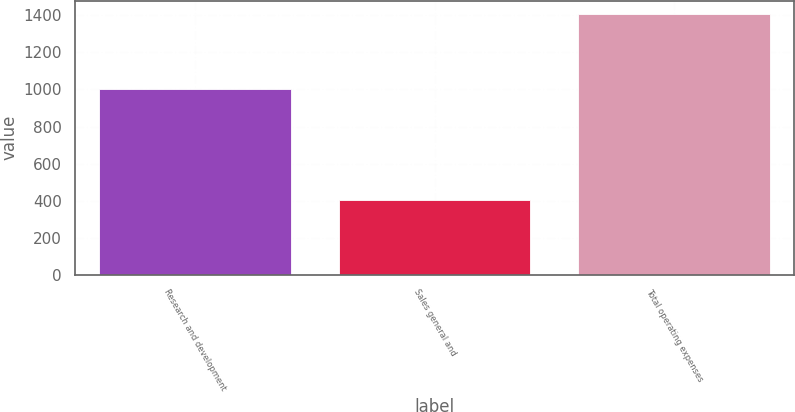Convert chart. <chart><loc_0><loc_0><loc_500><loc_500><bar_chart><fcel>Research and development<fcel>Sales general and<fcel>Total operating expenses<nl><fcel>1002.6<fcel>405.6<fcel>1408.2<nl></chart> 